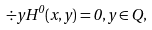<formula> <loc_0><loc_0><loc_500><loc_500>\div { y } { H ^ { 0 } ( x , y ) } = 0 , y \in Q ,</formula> 